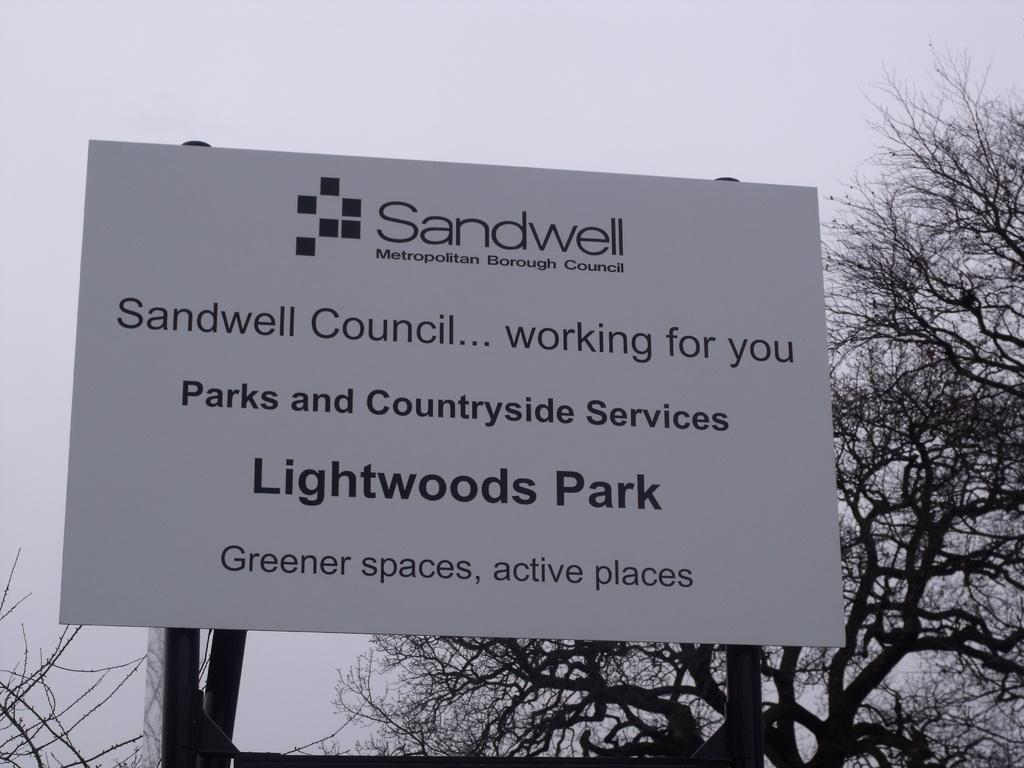What is on the board that is visible in the image? There is a board with text in the image. What other objects can be seen in the image? There are poles and trees visible in the image. What is visible in the background of the image? The sky is visible in the background of the image. Where is the soda located in the image? There is no soda or mention of soda in the image. What type of cap is being worn by the person in the image? There is no person or cap present in the image. 